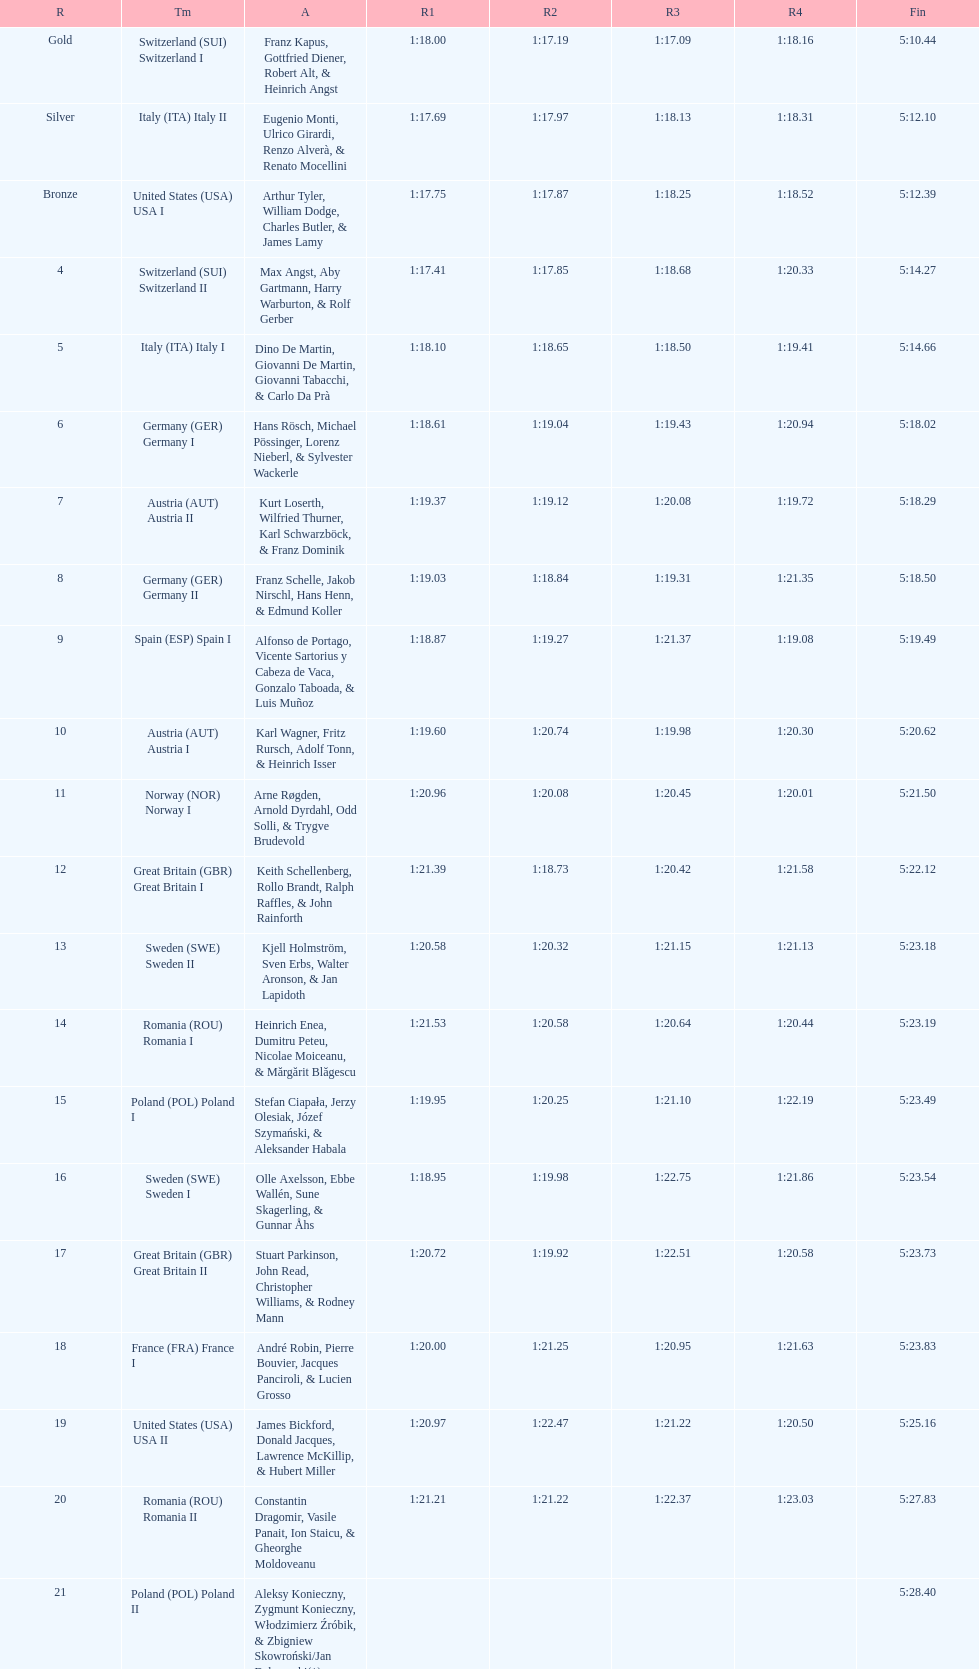Could you parse the entire table? {'header': ['R', 'Tm', 'A', 'R1', 'R2', 'R3', 'R4', 'Fin'], 'rows': [['Gold', 'Switzerland\xa0(SUI) Switzerland I', 'Franz Kapus, Gottfried Diener, Robert Alt, & Heinrich Angst', '1:18.00', '1:17.19', '1:17.09', '1:18.16', '5:10.44'], ['Silver', 'Italy\xa0(ITA) Italy II', 'Eugenio Monti, Ulrico Girardi, Renzo Alverà, & Renato Mocellini', '1:17.69', '1:17.97', '1:18.13', '1:18.31', '5:12.10'], ['Bronze', 'United States\xa0(USA) USA I', 'Arthur Tyler, William Dodge, Charles Butler, & James Lamy', '1:17.75', '1:17.87', '1:18.25', '1:18.52', '5:12.39'], ['4', 'Switzerland\xa0(SUI) Switzerland II', 'Max Angst, Aby Gartmann, Harry Warburton, & Rolf Gerber', '1:17.41', '1:17.85', '1:18.68', '1:20.33', '5:14.27'], ['5', 'Italy\xa0(ITA) Italy I', 'Dino De Martin, Giovanni De Martin, Giovanni Tabacchi, & Carlo Da Prà', '1:18.10', '1:18.65', '1:18.50', '1:19.41', '5:14.66'], ['6', 'Germany\xa0(GER) Germany I', 'Hans Rösch, Michael Pössinger, Lorenz Nieberl, & Sylvester Wackerle', '1:18.61', '1:19.04', '1:19.43', '1:20.94', '5:18.02'], ['7', 'Austria\xa0(AUT) Austria II', 'Kurt Loserth, Wilfried Thurner, Karl Schwarzböck, & Franz Dominik', '1:19.37', '1:19.12', '1:20.08', '1:19.72', '5:18.29'], ['8', 'Germany\xa0(GER) Germany II', 'Franz Schelle, Jakob Nirschl, Hans Henn, & Edmund Koller', '1:19.03', '1:18.84', '1:19.31', '1:21.35', '5:18.50'], ['9', 'Spain\xa0(ESP) Spain I', 'Alfonso de Portago, Vicente Sartorius y Cabeza de Vaca, Gonzalo Taboada, & Luis Muñoz', '1:18.87', '1:19.27', '1:21.37', '1:19.08', '5:19.49'], ['10', 'Austria\xa0(AUT) Austria I', 'Karl Wagner, Fritz Rursch, Adolf Tonn, & Heinrich Isser', '1:19.60', '1:20.74', '1:19.98', '1:20.30', '5:20.62'], ['11', 'Norway\xa0(NOR) Norway I', 'Arne Røgden, Arnold Dyrdahl, Odd Solli, & Trygve Brudevold', '1:20.96', '1:20.08', '1:20.45', '1:20.01', '5:21.50'], ['12', 'Great Britain\xa0(GBR) Great Britain I', 'Keith Schellenberg, Rollo Brandt, Ralph Raffles, & John Rainforth', '1:21.39', '1:18.73', '1:20.42', '1:21.58', '5:22.12'], ['13', 'Sweden\xa0(SWE) Sweden II', 'Kjell Holmström, Sven Erbs, Walter Aronson, & Jan Lapidoth', '1:20.58', '1:20.32', '1:21.15', '1:21.13', '5:23.18'], ['14', 'Romania\xa0(ROU) Romania I', 'Heinrich Enea, Dumitru Peteu, Nicolae Moiceanu, & Mărgărit Blăgescu', '1:21.53', '1:20.58', '1:20.64', '1:20.44', '5:23.19'], ['15', 'Poland\xa0(POL) Poland I', 'Stefan Ciapała, Jerzy Olesiak, Józef Szymański, & Aleksander Habala', '1:19.95', '1:20.25', '1:21.10', '1:22.19', '5:23.49'], ['16', 'Sweden\xa0(SWE) Sweden I', 'Olle Axelsson, Ebbe Wallén, Sune Skagerling, & Gunnar Åhs', '1:18.95', '1:19.98', '1:22.75', '1:21.86', '5:23.54'], ['17', 'Great Britain\xa0(GBR) Great Britain II', 'Stuart Parkinson, John Read, Christopher Williams, & Rodney Mann', '1:20.72', '1:19.92', '1:22.51', '1:20.58', '5:23.73'], ['18', 'France\xa0(FRA) France I', 'André Robin, Pierre Bouvier, Jacques Panciroli, & Lucien Grosso', '1:20.00', '1:21.25', '1:20.95', '1:21.63', '5:23.83'], ['19', 'United States\xa0(USA) USA II', 'James Bickford, Donald Jacques, Lawrence McKillip, & Hubert Miller', '1:20.97', '1:22.47', '1:21.22', '1:20.50', '5:25.16'], ['20', 'Romania\xa0(ROU) Romania II', 'Constantin Dragomir, Vasile Panait, Ion Staicu, & Gheorghe Moldoveanu', '1:21.21', '1:21.22', '1:22.37', '1:23.03', '5:27.83'], ['21', 'Poland\xa0(POL) Poland II', 'Aleksy Konieczny, Zygmunt Konieczny, Włodzimierz Źróbik, & Zbigniew Skowroński/Jan Dąbrowski(*)', '', '', '', '', '5:28.40']]} Name a country that had 4 consecutive runs under 1:19. Switzerland. 